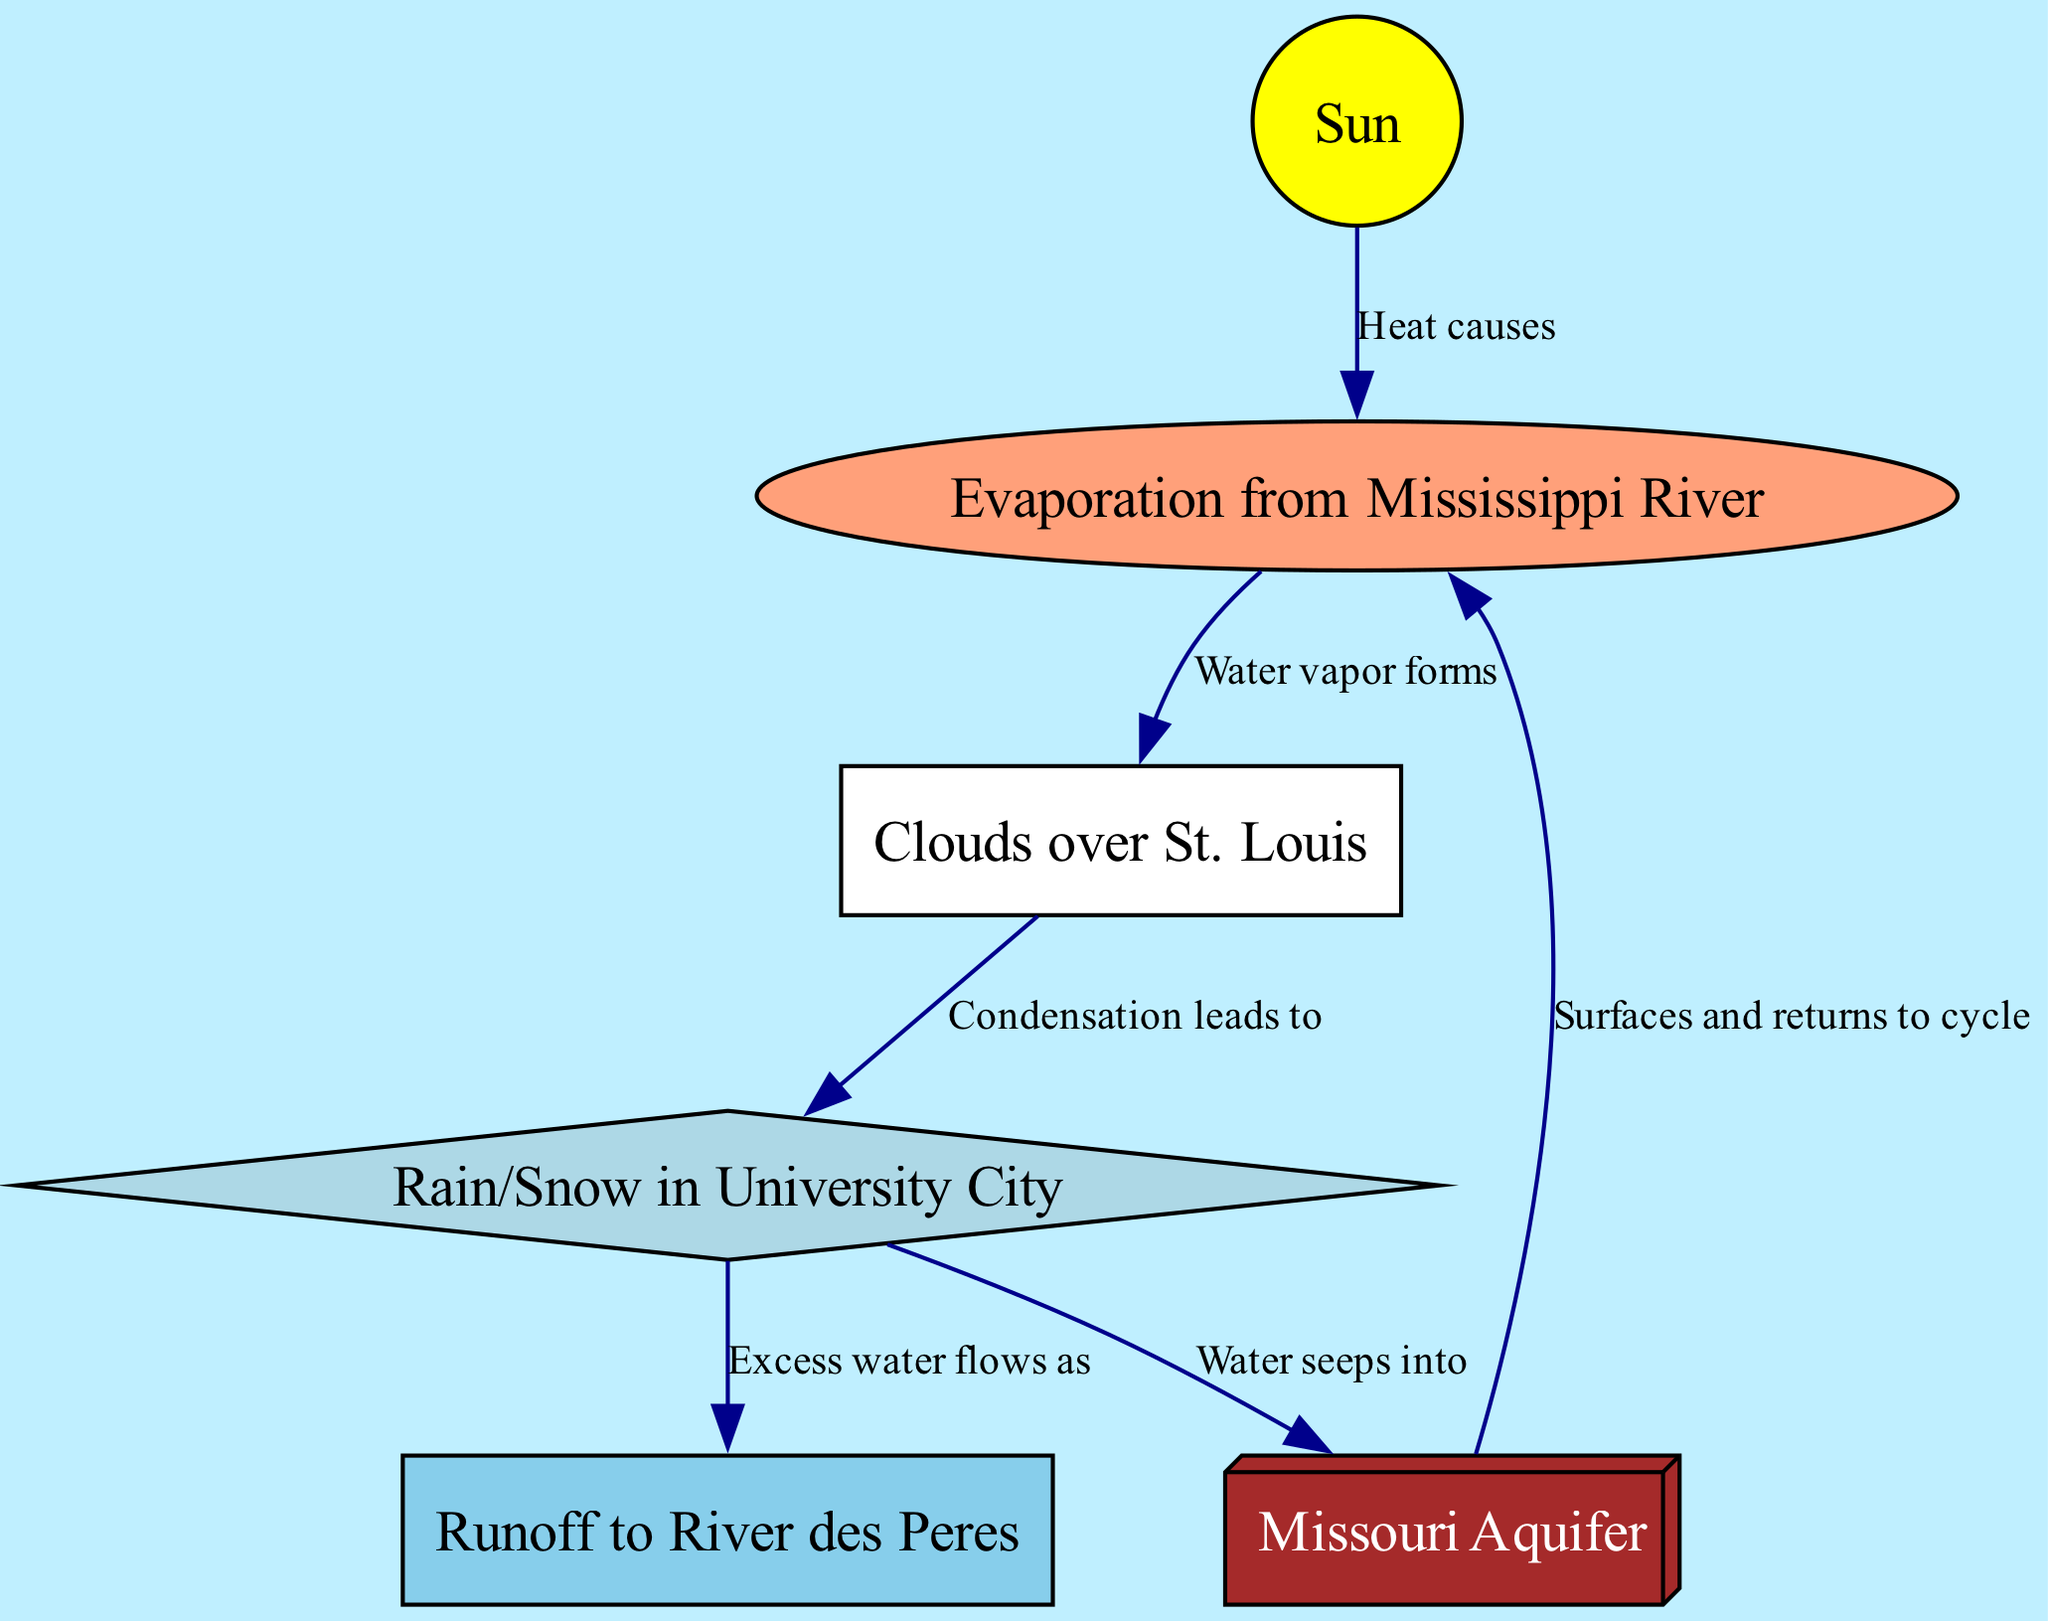What are the components of the water cycle shown in the diagram? The diagram includes six nodes representing components: Sun, Clouds over St. Louis, Rain/Snow in University City, Runoff to River des Peres, Evaporation from Mississippi River, and Missouri Aquifer. These components depict various stages in the water cycle.
Answer: Sun, Clouds over St. Louis, Rain/Snow in University City, Runoff to River des Peres, Evaporation from Mississippi River, Missouri Aquifer How many nodes are present in the diagram? The diagram contains six nodes that represent various elements of the water cycle, which help in visualizing the different processes involved.
Answer: 6 What process leads to the formation of clouds? From the diagram, evaporation from the Mississippi River produces water vapor, which then goes on to form clouds over St. Louis. This chain shows the progression from evaporation to cloud formation.
Answer: Water vapor forms What happens to excess water after precipitation? According to the diagram, excess water flows as runoff after precipitation occurs, indicating that not all water is absorbed into the ground or used directly. This shows the transition from precipitation to runoff.
Answer: Runoff to River des Peres Which component of the water cycle receives the water that seeps into the ground? The diagram indicates that water seeps into the Missouri Aquifer after precipitation, demonstrating the relationship between rainfall and groundwater accumulation in this specific aquifer.
Answer: Missouri Aquifer What role does the sun play in the water cycle? The diagram shows that heat from the sun causes evaporation to occur, highlighting the sun's essential function as a driving force behind the water cycle processes and their interconnections.
Answer: Heat causes How does groundwater contribute to the water cycle? The diagram indicates that water from the Missouri Aquifer surfaces and returns to the evaporation process, demonstrating the cyclical nature of how groundwater is integrated back into the atmosphere.
Answer: Surfaces and returns to cycle 